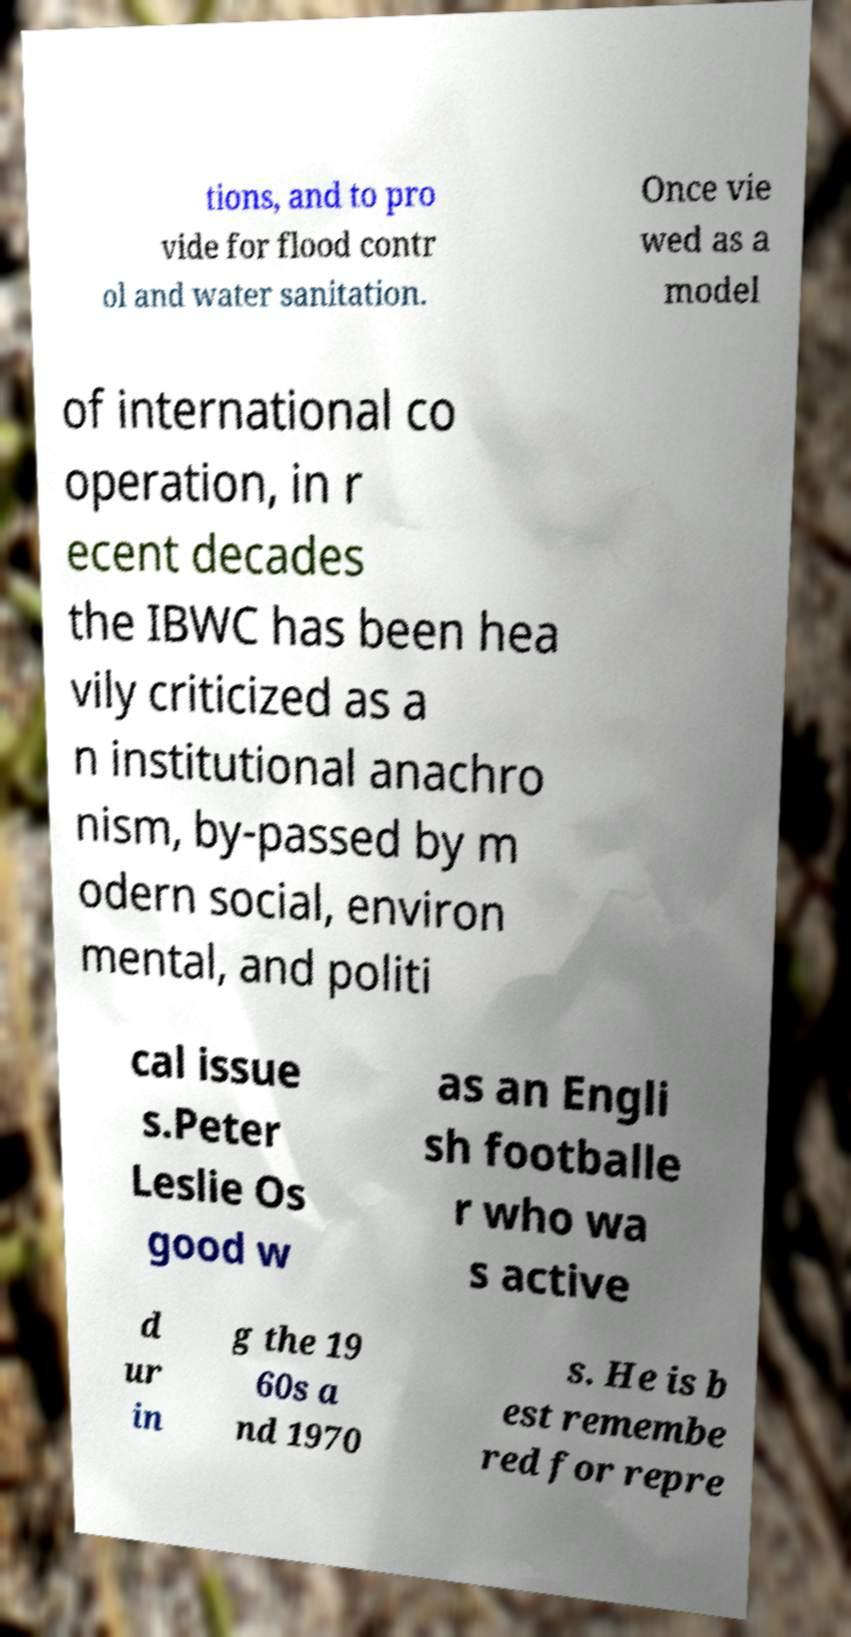Could you extract and type out the text from this image? tions, and to pro vide for flood contr ol and water sanitation. Once vie wed as a model of international co operation, in r ecent decades the IBWC has been hea vily criticized as a n institutional anachro nism, by-passed by m odern social, environ mental, and politi cal issue s.Peter Leslie Os good w as an Engli sh footballe r who wa s active d ur in g the 19 60s a nd 1970 s. He is b est remembe red for repre 